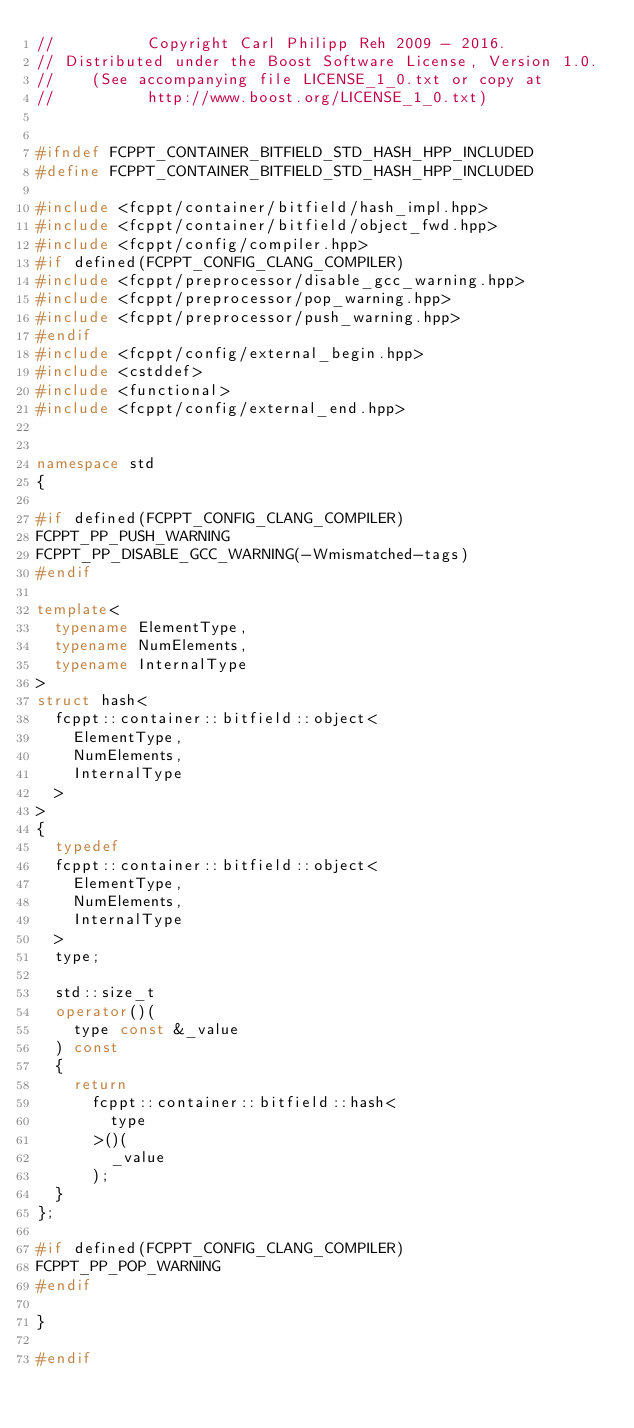Convert code to text. <code><loc_0><loc_0><loc_500><loc_500><_C++_>//          Copyright Carl Philipp Reh 2009 - 2016.
// Distributed under the Boost Software License, Version 1.0.
//    (See accompanying file LICENSE_1_0.txt or copy at
//          http://www.boost.org/LICENSE_1_0.txt)


#ifndef FCPPT_CONTAINER_BITFIELD_STD_HASH_HPP_INCLUDED
#define FCPPT_CONTAINER_BITFIELD_STD_HASH_HPP_INCLUDED

#include <fcppt/container/bitfield/hash_impl.hpp>
#include <fcppt/container/bitfield/object_fwd.hpp>
#include <fcppt/config/compiler.hpp>
#if defined(FCPPT_CONFIG_CLANG_COMPILER)
#include <fcppt/preprocessor/disable_gcc_warning.hpp>
#include <fcppt/preprocessor/pop_warning.hpp>
#include <fcppt/preprocessor/push_warning.hpp>
#endif
#include <fcppt/config/external_begin.hpp>
#include <cstddef>
#include <functional>
#include <fcppt/config/external_end.hpp>


namespace std
{

#if defined(FCPPT_CONFIG_CLANG_COMPILER)
FCPPT_PP_PUSH_WARNING
FCPPT_PP_DISABLE_GCC_WARNING(-Wmismatched-tags)
#endif

template<
	typename ElementType,
	typename NumElements,
	typename InternalType
>
struct hash<
	fcppt::container::bitfield::object<
		ElementType,
		NumElements,
		InternalType
	>
>
{
	typedef
	fcppt::container::bitfield::object<
		ElementType,
		NumElements,
		InternalType
	>
	type;

	std::size_t
	operator()(
		type const &_value
	) const
	{
		return
			fcppt::container::bitfield::hash<
				type
			>()(
				_value
			);
	}
};

#if defined(FCPPT_CONFIG_CLANG_COMPILER)
FCPPT_PP_POP_WARNING
#endif

}

#endif
</code> 